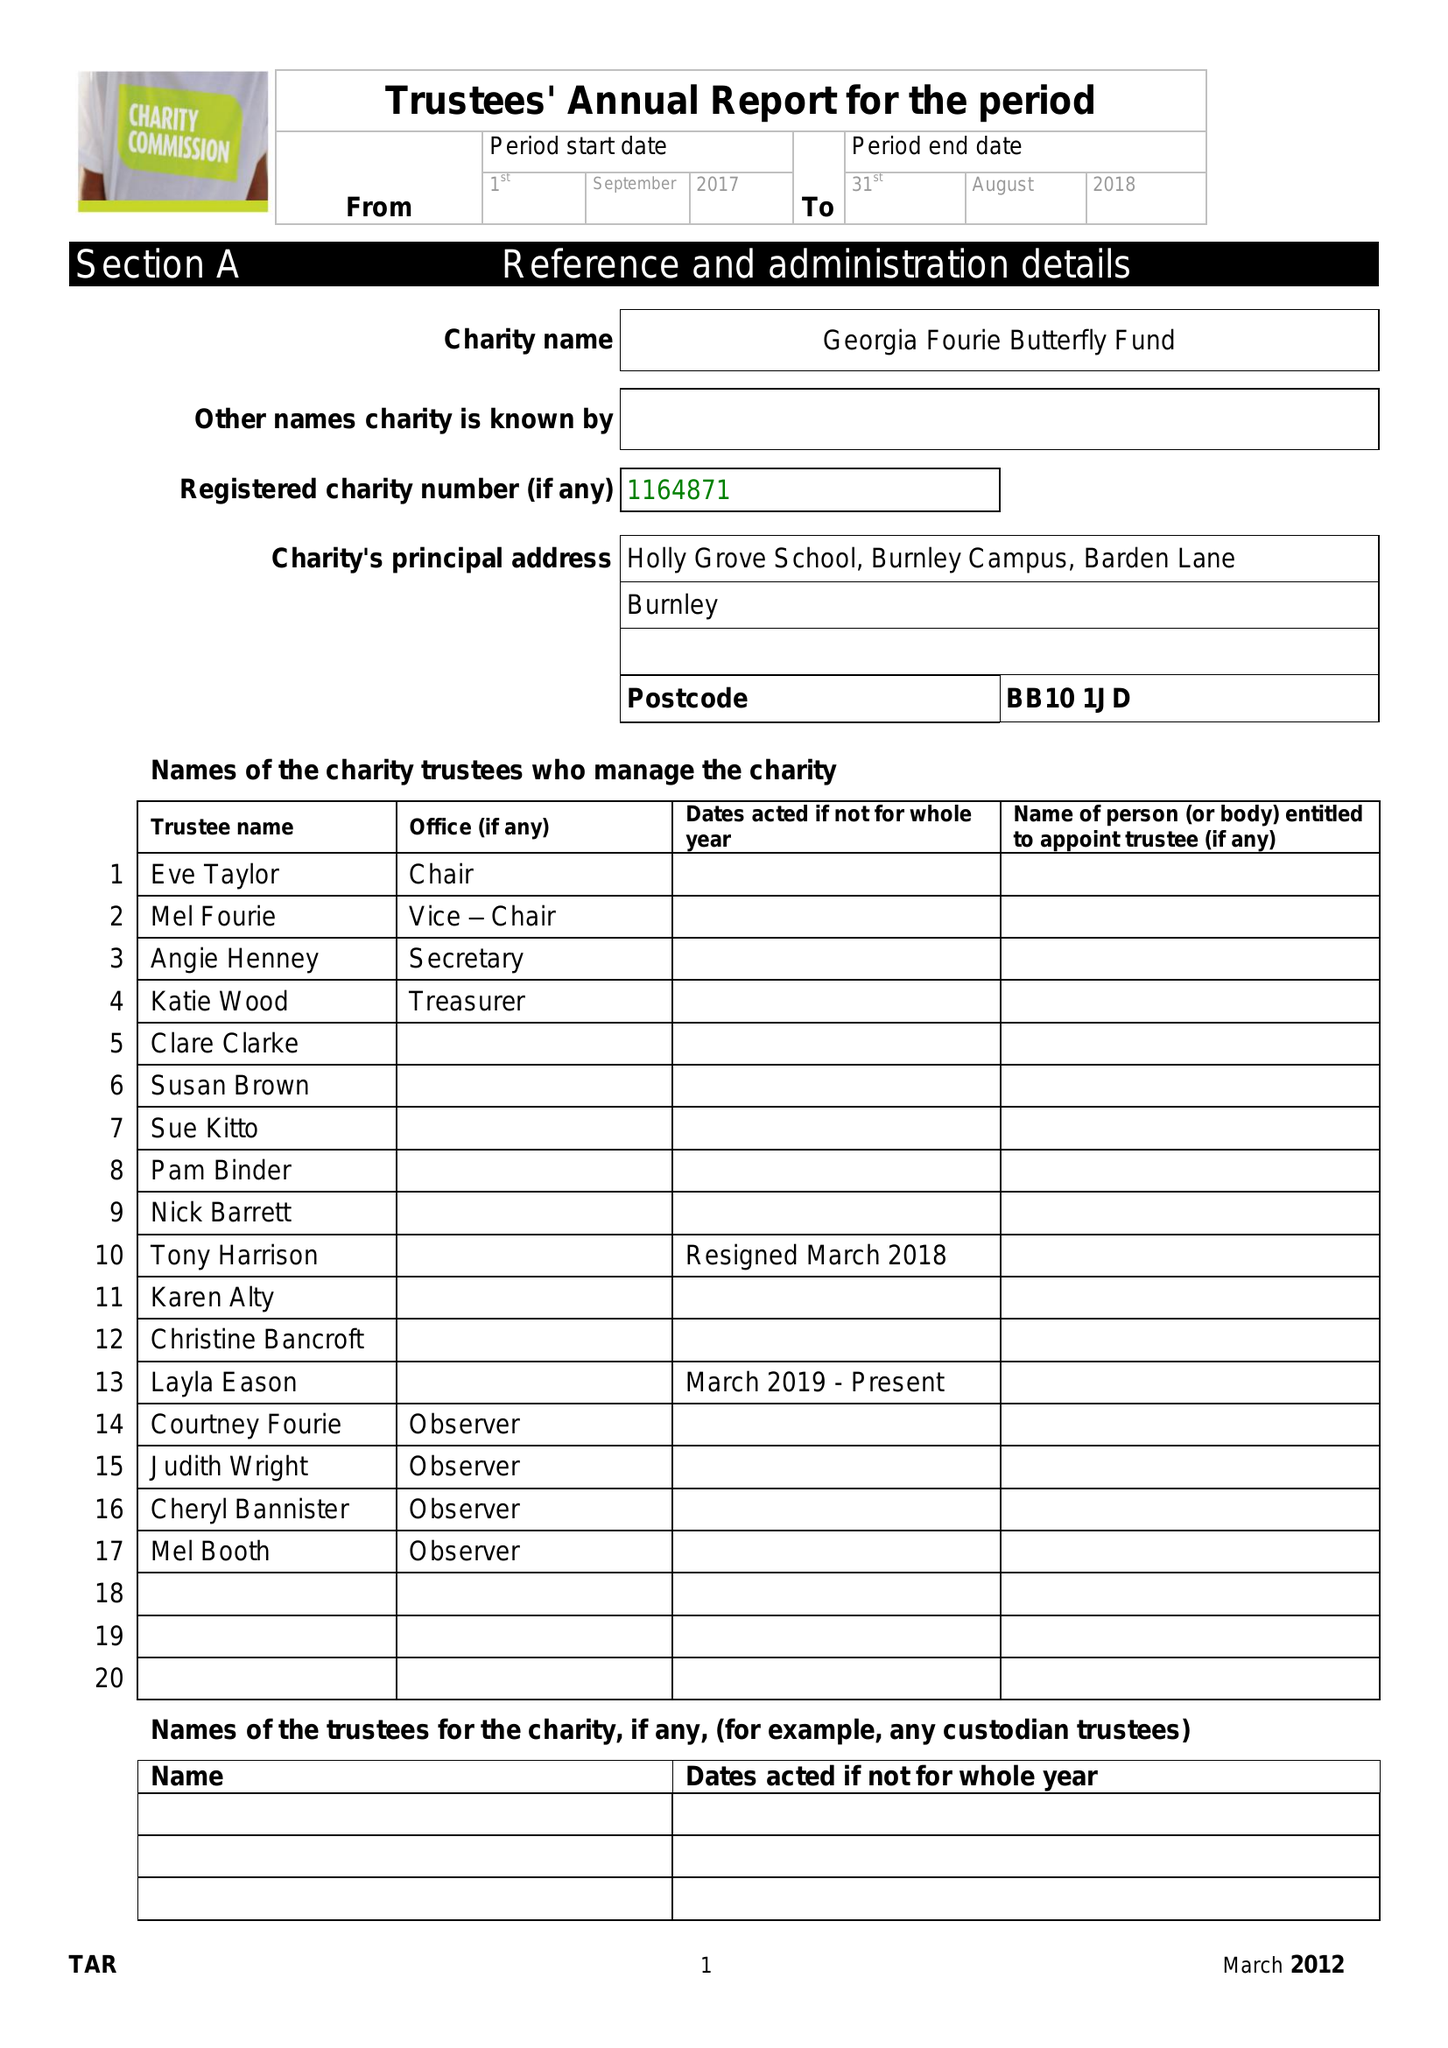What is the value for the address__street_line?
Answer the question using a single word or phrase. BARDEN LANE 